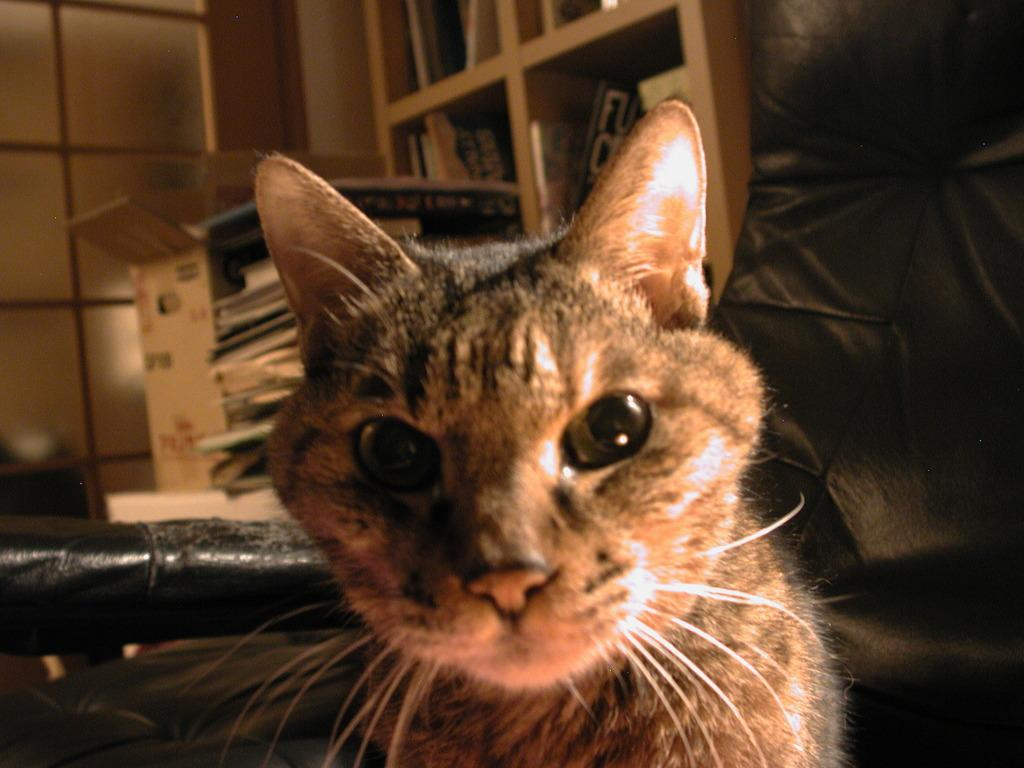What type of animal is in the image? There is a cat in the image. What can be seen in the background of the image? There are books arranged in shelves and a cardboard carton in the background. What else is present in the background of the image? There is a pile of papers in the background. What type of patch is the cat wearing on its trip? There is no mention of a patch or a trip in the image, and the cat is not wearing any clothing or accessories. 